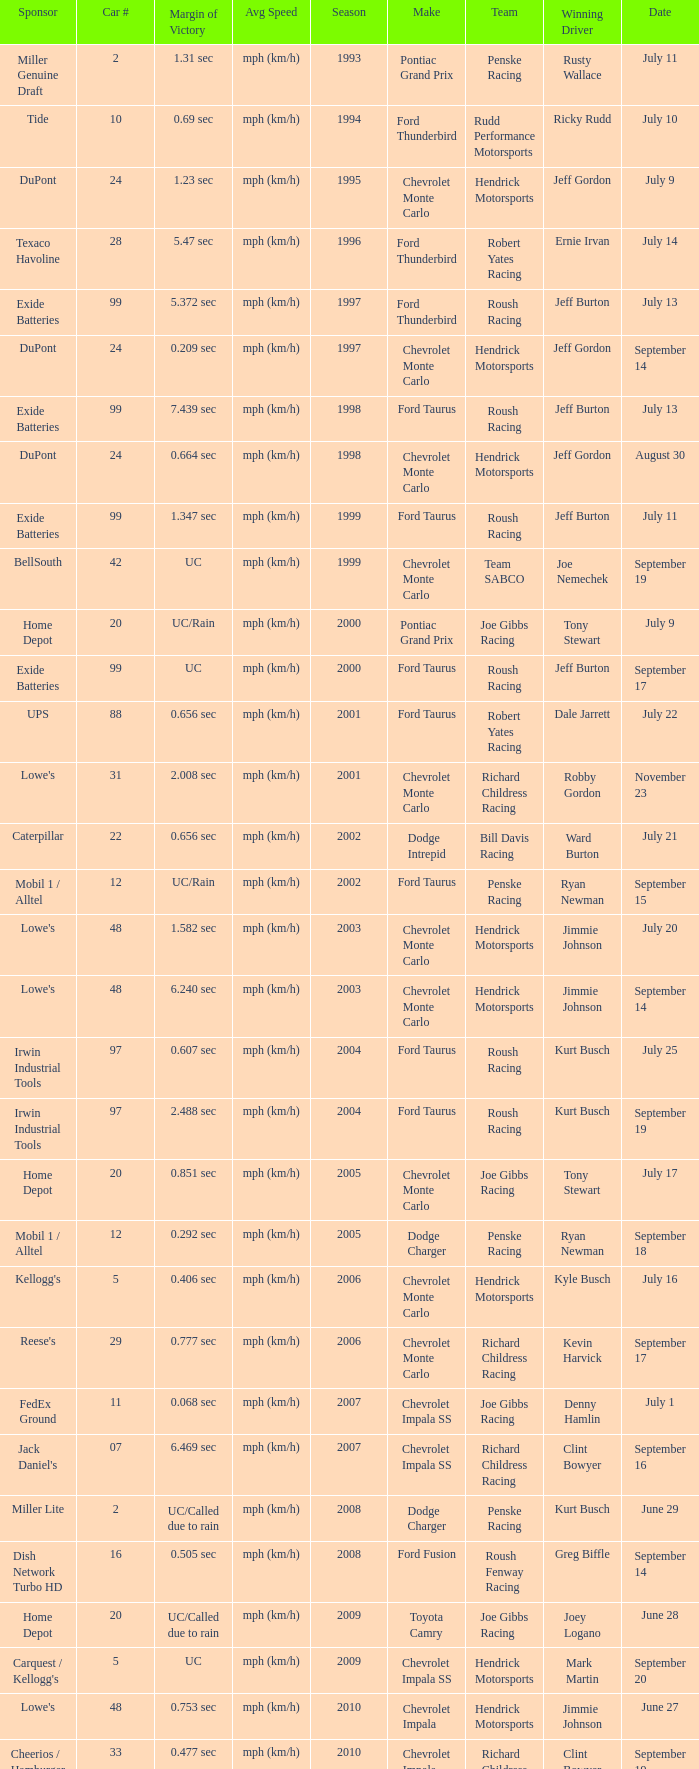What was the average speed of Tony Stewart's winning Chevrolet Impala? Mph (km/h). 